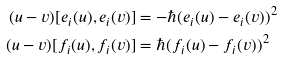Convert formula to latex. <formula><loc_0><loc_0><loc_500><loc_500>( u - v ) [ e _ { i } ( u ) , e _ { i } ( v ) ] & = - \hbar { ( } e _ { i } ( u ) - e _ { i } ( v ) ) ^ { 2 } \\ ( u - v ) [ f _ { i } ( u ) , f _ { i } ( v ) ] & = \hbar { ( } f _ { i } ( u ) - f _ { i } ( v ) ) ^ { 2 }</formula> 